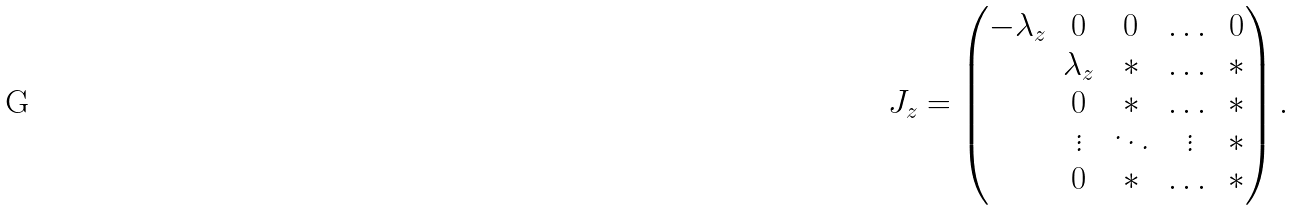Convert formula to latex. <formula><loc_0><loc_0><loc_500><loc_500>J _ { z } = \begin{pmatrix} - \lambda _ { z } & 0 & 0 & \dots & 0 \\ & \lambda _ { z } & * & \dots & * \\ & 0 & * & \dots & * \\ & \vdots & \ddots & \vdots & * \\ & 0 & * & \dots & * \end{pmatrix} .</formula> 